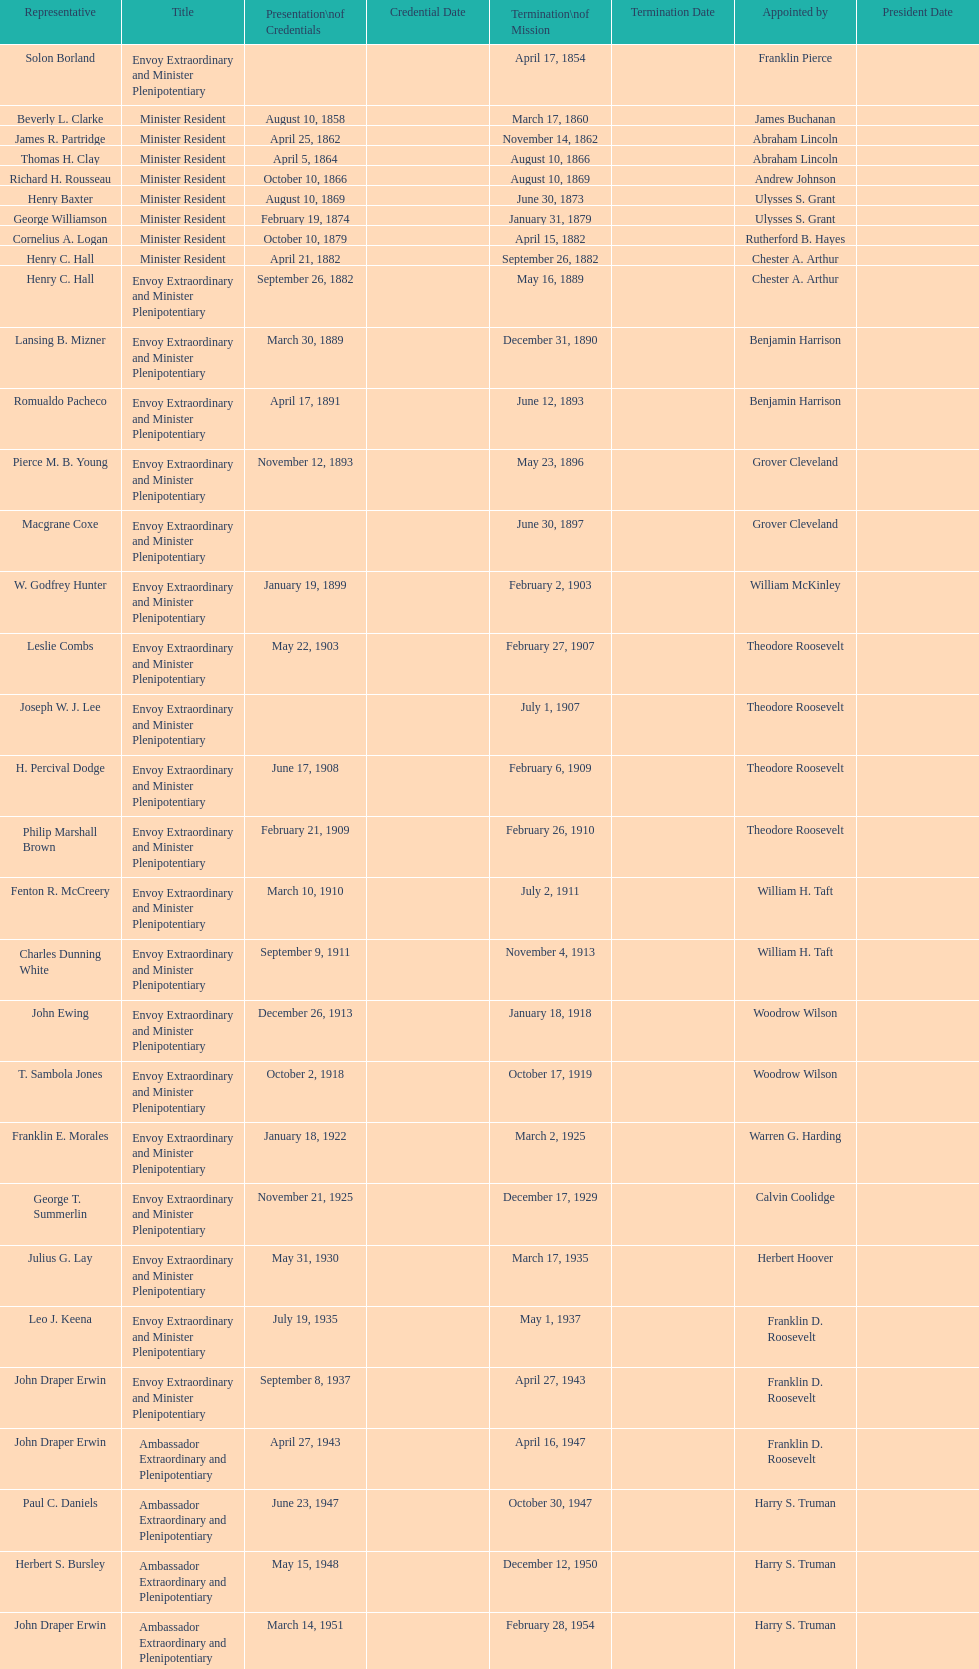What is the cumulative count of representatives? 50. 